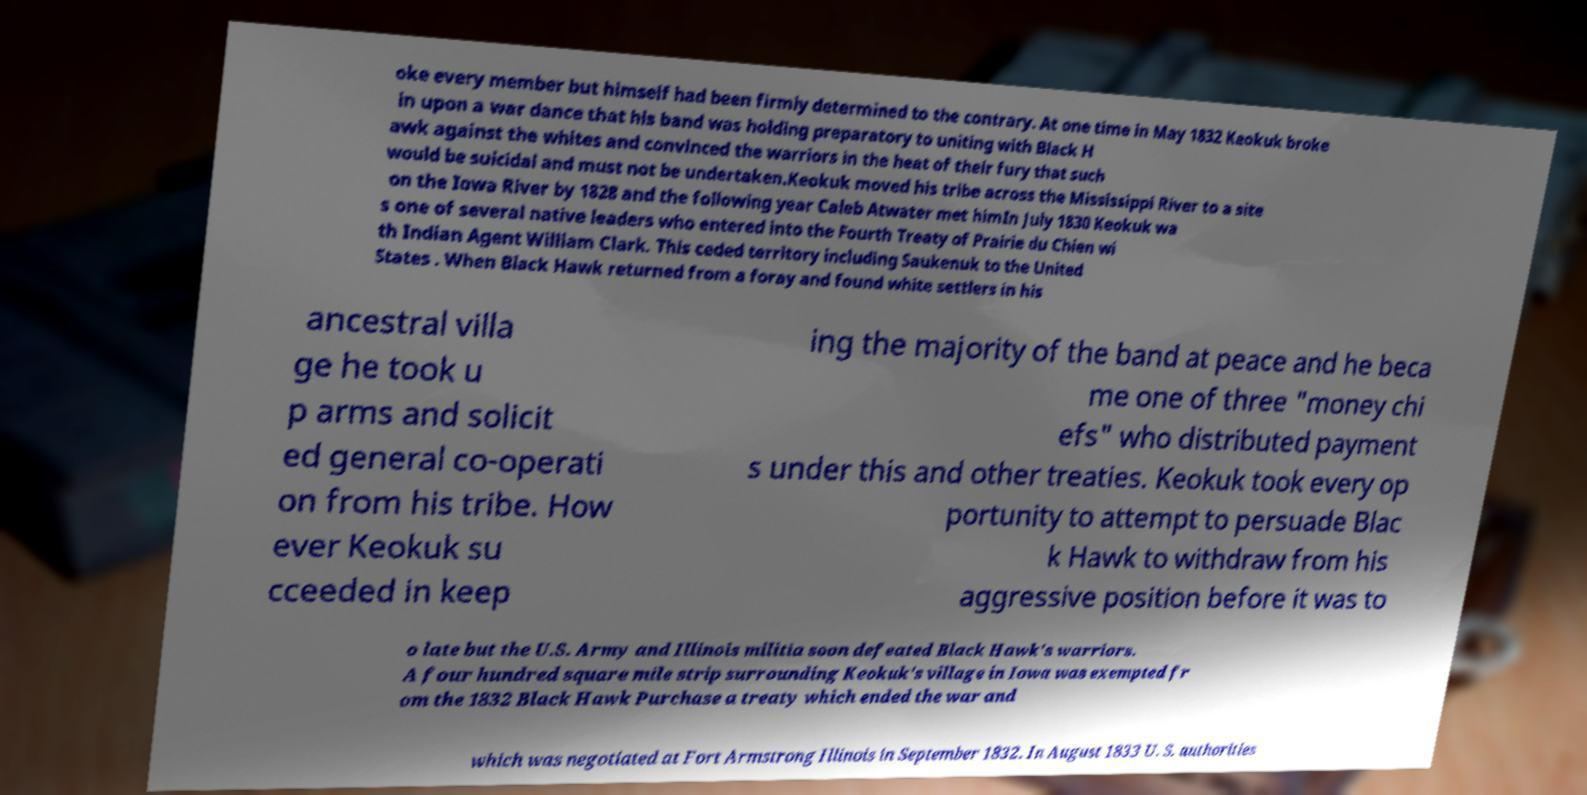Can you read and provide the text displayed in the image?This photo seems to have some interesting text. Can you extract and type it out for me? oke every member but himself had been firmly determined to the contrary. At one time in May 1832 Keokuk broke in upon a war dance that his band was holding preparatory to uniting with Black H awk against the whites and convinced the warriors in the heat of their fury that such would be suicidal and must not be undertaken.Keokuk moved his tribe across the Mississippi River to a site on the Iowa River by 1828 and the following year Caleb Atwater met himIn July 1830 Keokuk wa s one of several native leaders who entered into the Fourth Treaty of Prairie du Chien wi th Indian Agent William Clark. This ceded territory including Saukenuk to the United States . When Black Hawk returned from a foray and found white settlers in his ancestral villa ge he took u p arms and solicit ed general co-operati on from his tribe. How ever Keokuk su cceeded in keep ing the majority of the band at peace and he beca me one of three "money chi efs" who distributed payment s under this and other treaties. Keokuk took every op portunity to attempt to persuade Blac k Hawk to withdraw from his aggressive position before it was to o late but the U.S. Army and Illinois militia soon defeated Black Hawk's warriors. A four hundred square mile strip surrounding Keokuk's village in Iowa was exempted fr om the 1832 Black Hawk Purchase a treaty which ended the war and which was negotiated at Fort Armstrong Illinois in September 1832. In August 1833 U. S. authorities 